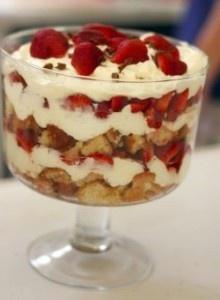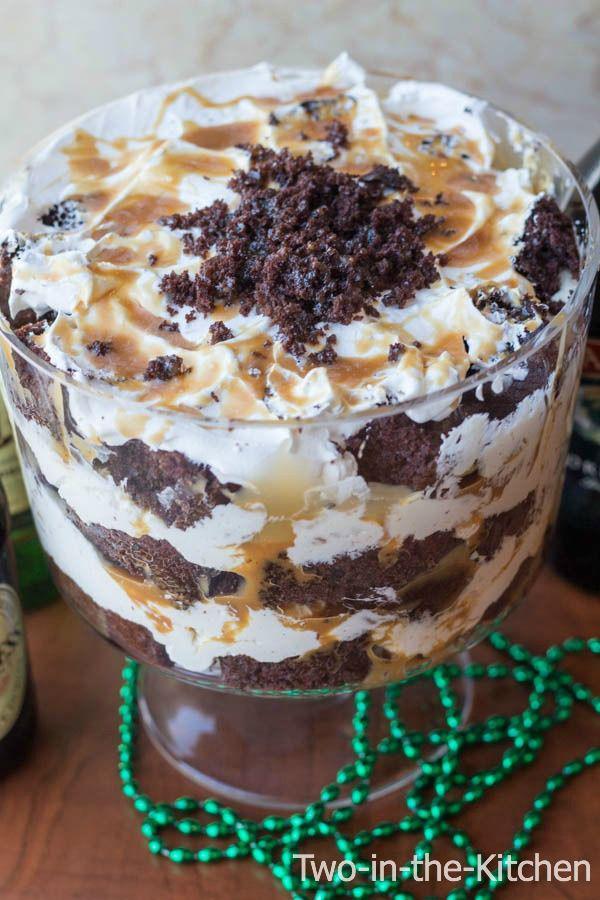The first image is the image on the left, the second image is the image on the right. Considering the images on both sides, is "An image shows one large dessert that is drizzled with caramel over the cream on top." valid? Answer yes or no. Yes. 